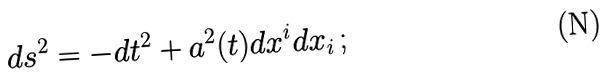<formula> <loc_0><loc_0><loc_500><loc_500>d s ^ { 2 } = - d t ^ { 2 } + a ^ { 2 } ( t ) d x ^ { i } d x _ { i } \, ;</formula> 